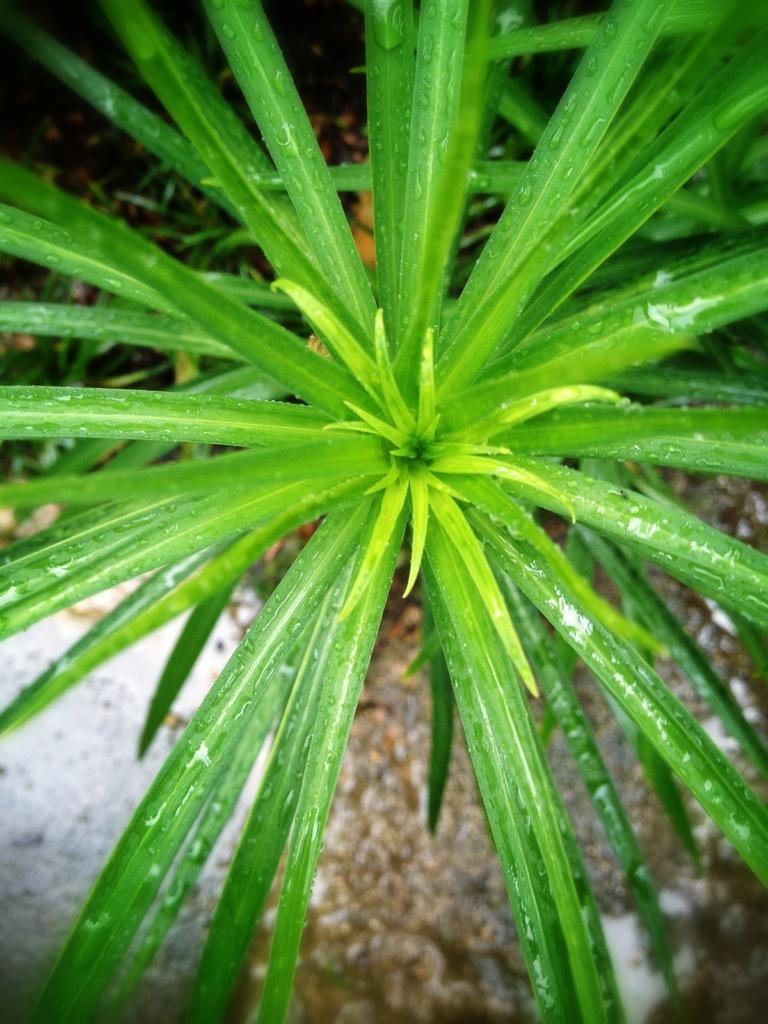Can you describe this image briefly? In this image, we can see some plants. We can see the ground with some objects. 